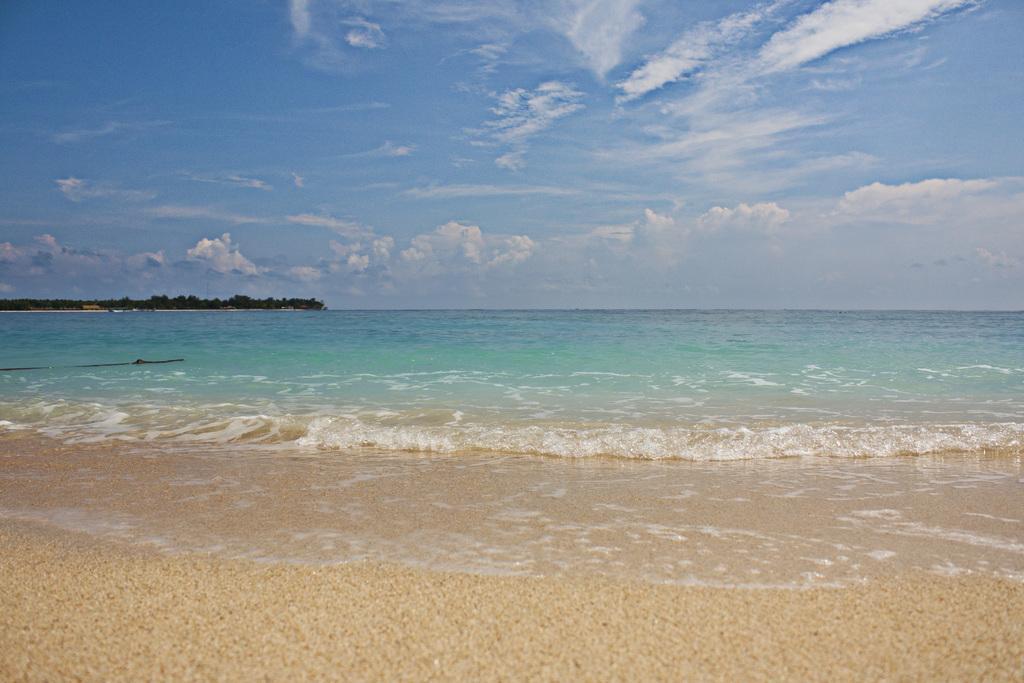In one or two sentences, can you explain what this image depicts? A picture of a beach. Sky is cloudy. This is a freshwater river. Far there are number of trees. 